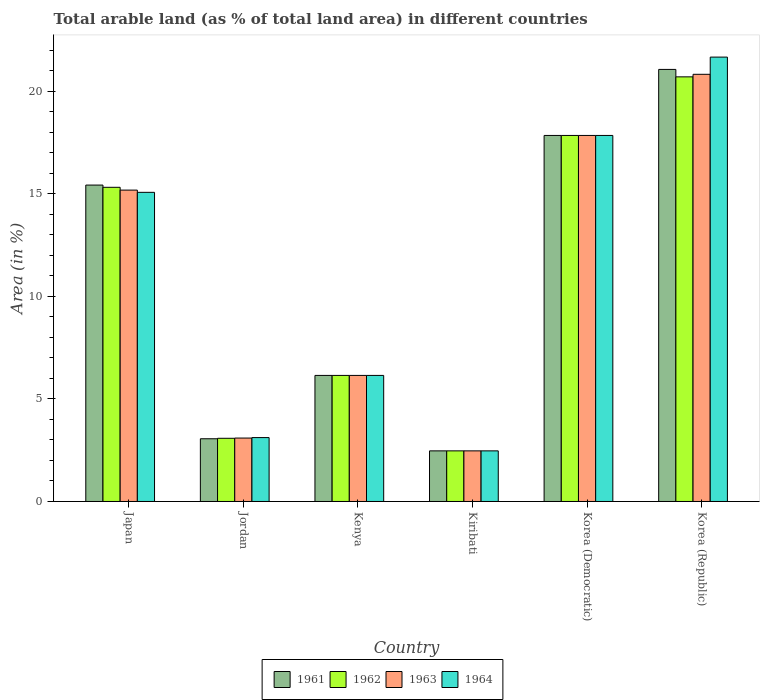How many different coloured bars are there?
Provide a succinct answer. 4. How many groups of bars are there?
Ensure brevity in your answer.  6. Are the number of bars on each tick of the X-axis equal?
Provide a short and direct response. Yes. How many bars are there on the 4th tick from the left?
Provide a short and direct response. 4. What is the label of the 5th group of bars from the left?
Your answer should be compact. Korea (Democratic). In how many cases, is the number of bars for a given country not equal to the number of legend labels?
Offer a terse response. 0. What is the percentage of arable land in 1964 in Japan?
Keep it short and to the point. 15.08. Across all countries, what is the maximum percentage of arable land in 1963?
Keep it short and to the point. 20.84. Across all countries, what is the minimum percentage of arable land in 1962?
Keep it short and to the point. 2.47. In which country was the percentage of arable land in 1962 maximum?
Offer a very short reply. Korea (Republic). In which country was the percentage of arable land in 1964 minimum?
Provide a succinct answer. Kiribati. What is the total percentage of arable land in 1962 in the graph?
Give a very brief answer. 65.6. What is the difference between the percentage of arable land in 1963 in Korea (Democratic) and that in Korea (Republic)?
Offer a very short reply. -2.98. What is the difference between the percentage of arable land in 1962 in Kiribati and the percentage of arable land in 1964 in Kenya?
Offer a terse response. -3.68. What is the average percentage of arable land in 1964 per country?
Make the answer very short. 11.06. What is the ratio of the percentage of arable land in 1964 in Japan to that in Kiribati?
Offer a terse response. 6.11. Is the percentage of arable land in 1963 in Kenya less than that in Kiribati?
Ensure brevity in your answer.  No. Is the difference between the percentage of arable land in 1964 in Jordan and Kiribati greater than the difference between the percentage of arable land in 1963 in Jordan and Kiribati?
Your response must be concise. Yes. What is the difference between the highest and the second highest percentage of arable land in 1963?
Your response must be concise. -2.98. What is the difference between the highest and the lowest percentage of arable land in 1964?
Your response must be concise. 19.21. Is it the case that in every country, the sum of the percentage of arable land in 1961 and percentage of arable land in 1964 is greater than the sum of percentage of arable land in 1963 and percentage of arable land in 1962?
Your answer should be compact. No. What does the 3rd bar from the left in Kenya represents?
Make the answer very short. 1963. How many bars are there?
Offer a very short reply. 24. Are all the bars in the graph horizontal?
Ensure brevity in your answer.  No. How many countries are there in the graph?
Provide a short and direct response. 6. What is the difference between two consecutive major ticks on the Y-axis?
Provide a short and direct response. 5. Does the graph contain grids?
Your answer should be compact. No. How many legend labels are there?
Provide a succinct answer. 4. What is the title of the graph?
Ensure brevity in your answer.  Total arable land (as % of total land area) in different countries. What is the label or title of the Y-axis?
Offer a very short reply. Area (in %). What is the Area (in %) of 1961 in Japan?
Provide a succinct answer. 15.43. What is the Area (in %) in 1962 in Japan?
Offer a very short reply. 15.33. What is the Area (in %) of 1963 in Japan?
Keep it short and to the point. 15.19. What is the Area (in %) of 1964 in Japan?
Provide a short and direct response. 15.08. What is the Area (in %) in 1961 in Jordan?
Your response must be concise. 3.06. What is the Area (in %) of 1962 in Jordan?
Offer a very short reply. 3.08. What is the Area (in %) of 1963 in Jordan?
Keep it short and to the point. 3.09. What is the Area (in %) in 1964 in Jordan?
Give a very brief answer. 3.12. What is the Area (in %) of 1961 in Kenya?
Provide a short and direct response. 6.15. What is the Area (in %) in 1962 in Kenya?
Offer a terse response. 6.15. What is the Area (in %) in 1963 in Kenya?
Ensure brevity in your answer.  6.15. What is the Area (in %) of 1964 in Kenya?
Offer a terse response. 6.15. What is the Area (in %) in 1961 in Kiribati?
Provide a short and direct response. 2.47. What is the Area (in %) of 1962 in Kiribati?
Your response must be concise. 2.47. What is the Area (in %) of 1963 in Kiribati?
Your response must be concise. 2.47. What is the Area (in %) of 1964 in Kiribati?
Provide a succinct answer. 2.47. What is the Area (in %) in 1961 in Korea (Democratic)?
Provide a short and direct response. 17.86. What is the Area (in %) of 1962 in Korea (Democratic)?
Make the answer very short. 17.86. What is the Area (in %) in 1963 in Korea (Democratic)?
Ensure brevity in your answer.  17.86. What is the Area (in %) in 1964 in Korea (Democratic)?
Offer a very short reply. 17.86. What is the Area (in %) of 1961 in Korea (Republic)?
Your answer should be compact. 21.08. What is the Area (in %) of 1962 in Korea (Republic)?
Provide a short and direct response. 20.71. What is the Area (in %) in 1963 in Korea (Republic)?
Keep it short and to the point. 20.84. What is the Area (in %) in 1964 in Korea (Republic)?
Give a very brief answer. 21.68. Across all countries, what is the maximum Area (in %) in 1961?
Keep it short and to the point. 21.08. Across all countries, what is the maximum Area (in %) in 1962?
Provide a short and direct response. 20.71. Across all countries, what is the maximum Area (in %) of 1963?
Keep it short and to the point. 20.84. Across all countries, what is the maximum Area (in %) of 1964?
Provide a short and direct response. 21.68. Across all countries, what is the minimum Area (in %) of 1961?
Your response must be concise. 2.47. Across all countries, what is the minimum Area (in %) of 1962?
Your answer should be very brief. 2.47. Across all countries, what is the minimum Area (in %) in 1963?
Offer a terse response. 2.47. Across all countries, what is the minimum Area (in %) in 1964?
Offer a terse response. 2.47. What is the total Area (in %) in 1961 in the graph?
Your response must be concise. 66.05. What is the total Area (in %) in 1962 in the graph?
Give a very brief answer. 65.6. What is the total Area (in %) in 1963 in the graph?
Ensure brevity in your answer.  65.6. What is the total Area (in %) of 1964 in the graph?
Provide a succinct answer. 66.35. What is the difference between the Area (in %) of 1961 in Japan and that in Jordan?
Offer a terse response. 12.38. What is the difference between the Area (in %) in 1962 in Japan and that in Jordan?
Keep it short and to the point. 12.24. What is the difference between the Area (in %) in 1963 in Japan and that in Jordan?
Offer a terse response. 12.1. What is the difference between the Area (in %) in 1964 in Japan and that in Jordan?
Your answer should be compact. 11.96. What is the difference between the Area (in %) in 1961 in Japan and that in Kenya?
Ensure brevity in your answer.  9.29. What is the difference between the Area (in %) of 1962 in Japan and that in Kenya?
Your response must be concise. 9.18. What is the difference between the Area (in %) of 1963 in Japan and that in Kenya?
Offer a terse response. 9.04. What is the difference between the Area (in %) of 1964 in Japan and that in Kenya?
Provide a succinct answer. 8.93. What is the difference between the Area (in %) of 1961 in Japan and that in Kiribati?
Ensure brevity in your answer.  12.97. What is the difference between the Area (in %) of 1962 in Japan and that in Kiribati?
Ensure brevity in your answer.  12.86. What is the difference between the Area (in %) in 1963 in Japan and that in Kiribati?
Make the answer very short. 12.72. What is the difference between the Area (in %) in 1964 in Japan and that in Kiribati?
Your response must be concise. 12.61. What is the difference between the Area (in %) of 1961 in Japan and that in Korea (Democratic)?
Provide a succinct answer. -2.42. What is the difference between the Area (in %) in 1962 in Japan and that in Korea (Democratic)?
Provide a short and direct response. -2.53. What is the difference between the Area (in %) of 1963 in Japan and that in Korea (Democratic)?
Make the answer very short. -2.67. What is the difference between the Area (in %) in 1964 in Japan and that in Korea (Democratic)?
Your answer should be compact. -2.78. What is the difference between the Area (in %) in 1961 in Japan and that in Korea (Republic)?
Make the answer very short. -5.64. What is the difference between the Area (in %) in 1962 in Japan and that in Korea (Republic)?
Keep it short and to the point. -5.39. What is the difference between the Area (in %) in 1963 in Japan and that in Korea (Republic)?
Provide a succinct answer. -5.65. What is the difference between the Area (in %) in 1964 in Japan and that in Korea (Republic)?
Make the answer very short. -6.6. What is the difference between the Area (in %) in 1961 in Jordan and that in Kenya?
Keep it short and to the point. -3.09. What is the difference between the Area (in %) in 1962 in Jordan and that in Kenya?
Your answer should be very brief. -3.07. What is the difference between the Area (in %) in 1963 in Jordan and that in Kenya?
Keep it short and to the point. -3.06. What is the difference between the Area (in %) of 1964 in Jordan and that in Kenya?
Your answer should be very brief. -3.03. What is the difference between the Area (in %) of 1961 in Jordan and that in Kiribati?
Give a very brief answer. 0.59. What is the difference between the Area (in %) in 1962 in Jordan and that in Kiribati?
Make the answer very short. 0.61. What is the difference between the Area (in %) of 1963 in Jordan and that in Kiribati?
Ensure brevity in your answer.  0.62. What is the difference between the Area (in %) of 1964 in Jordan and that in Kiribati?
Your answer should be very brief. 0.65. What is the difference between the Area (in %) in 1961 in Jordan and that in Korea (Democratic)?
Give a very brief answer. -14.8. What is the difference between the Area (in %) of 1962 in Jordan and that in Korea (Democratic)?
Offer a very short reply. -14.77. What is the difference between the Area (in %) of 1963 in Jordan and that in Korea (Democratic)?
Make the answer very short. -14.76. What is the difference between the Area (in %) in 1964 in Jordan and that in Korea (Democratic)?
Make the answer very short. -14.74. What is the difference between the Area (in %) of 1961 in Jordan and that in Korea (Republic)?
Your answer should be very brief. -18.02. What is the difference between the Area (in %) in 1962 in Jordan and that in Korea (Republic)?
Keep it short and to the point. -17.63. What is the difference between the Area (in %) of 1963 in Jordan and that in Korea (Republic)?
Offer a terse response. -17.74. What is the difference between the Area (in %) in 1964 in Jordan and that in Korea (Republic)?
Give a very brief answer. -18.56. What is the difference between the Area (in %) in 1961 in Kenya and that in Kiribati?
Your response must be concise. 3.68. What is the difference between the Area (in %) of 1962 in Kenya and that in Kiribati?
Your answer should be compact. 3.68. What is the difference between the Area (in %) of 1963 in Kenya and that in Kiribati?
Provide a short and direct response. 3.68. What is the difference between the Area (in %) in 1964 in Kenya and that in Kiribati?
Offer a very short reply. 3.68. What is the difference between the Area (in %) of 1961 in Kenya and that in Korea (Democratic)?
Your response must be concise. -11.71. What is the difference between the Area (in %) of 1962 in Kenya and that in Korea (Democratic)?
Ensure brevity in your answer.  -11.71. What is the difference between the Area (in %) of 1963 in Kenya and that in Korea (Democratic)?
Your answer should be compact. -11.71. What is the difference between the Area (in %) of 1964 in Kenya and that in Korea (Democratic)?
Give a very brief answer. -11.71. What is the difference between the Area (in %) of 1961 in Kenya and that in Korea (Republic)?
Give a very brief answer. -14.93. What is the difference between the Area (in %) in 1962 in Kenya and that in Korea (Republic)?
Your answer should be very brief. -14.56. What is the difference between the Area (in %) of 1963 in Kenya and that in Korea (Republic)?
Offer a terse response. -14.69. What is the difference between the Area (in %) of 1964 in Kenya and that in Korea (Republic)?
Provide a succinct answer. -15.53. What is the difference between the Area (in %) in 1961 in Kiribati and that in Korea (Democratic)?
Provide a short and direct response. -15.39. What is the difference between the Area (in %) in 1962 in Kiribati and that in Korea (Democratic)?
Ensure brevity in your answer.  -15.39. What is the difference between the Area (in %) in 1963 in Kiribati and that in Korea (Democratic)?
Make the answer very short. -15.39. What is the difference between the Area (in %) in 1964 in Kiribati and that in Korea (Democratic)?
Ensure brevity in your answer.  -15.39. What is the difference between the Area (in %) of 1961 in Kiribati and that in Korea (Republic)?
Ensure brevity in your answer.  -18.61. What is the difference between the Area (in %) in 1962 in Kiribati and that in Korea (Republic)?
Your answer should be compact. -18.24. What is the difference between the Area (in %) of 1963 in Kiribati and that in Korea (Republic)?
Offer a terse response. -18.37. What is the difference between the Area (in %) in 1964 in Kiribati and that in Korea (Republic)?
Your response must be concise. -19.21. What is the difference between the Area (in %) in 1961 in Korea (Democratic) and that in Korea (Republic)?
Give a very brief answer. -3.22. What is the difference between the Area (in %) of 1962 in Korea (Democratic) and that in Korea (Republic)?
Your answer should be very brief. -2.86. What is the difference between the Area (in %) of 1963 in Korea (Democratic) and that in Korea (Republic)?
Give a very brief answer. -2.98. What is the difference between the Area (in %) of 1964 in Korea (Democratic) and that in Korea (Republic)?
Keep it short and to the point. -3.82. What is the difference between the Area (in %) of 1961 in Japan and the Area (in %) of 1962 in Jordan?
Your answer should be compact. 12.35. What is the difference between the Area (in %) of 1961 in Japan and the Area (in %) of 1963 in Jordan?
Offer a terse response. 12.34. What is the difference between the Area (in %) of 1961 in Japan and the Area (in %) of 1964 in Jordan?
Ensure brevity in your answer.  12.32. What is the difference between the Area (in %) of 1962 in Japan and the Area (in %) of 1963 in Jordan?
Provide a short and direct response. 12.23. What is the difference between the Area (in %) of 1962 in Japan and the Area (in %) of 1964 in Jordan?
Offer a terse response. 12.21. What is the difference between the Area (in %) of 1963 in Japan and the Area (in %) of 1964 in Jordan?
Ensure brevity in your answer.  12.07. What is the difference between the Area (in %) in 1961 in Japan and the Area (in %) in 1962 in Kenya?
Provide a short and direct response. 9.29. What is the difference between the Area (in %) in 1961 in Japan and the Area (in %) in 1963 in Kenya?
Offer a terse response. 9.29. What is the difference between the Area (in %) of 1961 in Japan and the Area (in %) of 1964 in Kenya?
Give a very brief answer. 9.29. What is the difference between the Area (in %) of 1962 in Japan and the Area (in %) of 1963 in Kenya?
Keep it short and to the point. 9.18. What is the difference between the Area (in %) in 1962 in Japan and the Area (in %) in 1964 in Kenya?
Make the answer very short. 9.18. What is the difference between the Area (in %) of 1963 in Japan and the Area (in %) of 1964 in Kenya?
Provide a short and direct response. 9.04. What is the difference between the Area (in %) in 1961 in Japan and the Area (in %) in 1962 in Kiribati?
Offer a very short reply. 12.97. What is the difference between the Area (in %) in 1961 in Japan and the Area (in %) in 1963 in Kiribati?
Provide a short and direct response. 12.97. What is the difference between the Area (in %) of 1961 in Japan and the Area (in %) of 1964 in Kiribati?
Make the answer very short. 12.97. What is the difference between the Area (in %) in 1962 in Japan and the Area (in %) in 1963 in Kiribati?
Your answer should be compact. 12.86. What is the difference between the Area (in %) in 1962 in Japan and the Area (in %) in 1964 in Kiribati?
Your answer should be compact. 12.86. What is the difference between the Area (in %) in 1963 in Japan and the Area (in %) in 1964 in Kiribati?
Provide a succinct answer. 12.72. What is the difference between the Area (in %) of 1961 in Japan and the Area (in %) of 1962 in Korea (Democratic)?
Provide a short and direct response. -2.42. What is the difference between the Area (in %) of 1961 in Japan and the Area (in %) of 1963 in Korea (Democratic)?
Your answer should be very brief. -2.42. What is the difference between the Area (in %) of 1961 in Japan and the Area (in %) of 1964 in Korea (Democratic)?
Keep it short and to the point. -2.42. What is the difference between the Area (in %) of 1962 in Japan and the Area (in %) of 1963 in Korea (Democratic)?
Offer a very short reply. -2.53. What is the difference between the Area (in %) of 1962 in Japan and the Area (in %) of 1964 in Korea (Democratic)?
Your answer should be very brief. -2.53. What is the difference between the Area (in %) in 1963 in Japan and the Area (in %) in 1964 in Korea (Democratic)?
Offer a terse response. -2.67. What is the difference between the Area (in %) of 1961 in Japan and the Area (in %) of 1962 in Korea (Republic)?
Your response must be concise. -5.28. What is the difference between the Area (in %) of 1961 in Japan and the Area (in %) of 1963 in Korea (Republic)?
Provide a short and direct response. -5.4. What is the difference between the Area (in %) of 1961 in Japan and the Area (in %) of 1964 in Korea (Republic)?
Your response must be concise. -6.24. What is the difference between the Area (in %) of 1962 in Japan and the Area (in %) of 1963 in Korea (Republic)?
Ensure brevity in your answer.  -5.51. What is the difference between the Area (in %) of 1962 in Japan and the Area (in %) of 1964 in Korea (Republic)?
Your answer should be compact. -6.35. What is the difference between the Area (in %) in 1963 in Japan and the Area (in %) in 1964 in Korea (Republic)?
Offer a very short reply. -6.49. What is the difference between the Area (in %) of 1961 in Jordan and the Area (in %) of 1962 in Kenya?
Your response must be concise. -3.09. What is the difference between the Area (in %) of 1961 in Jordan and the Area (in %) of 1963 in Kenya?
Your response must be concise. -3.09. What is the difference between the Area (in %) of 1961 in Jordan and the Area (in %) of 1964 in Kenya?
Your response must be concise. -3.09. What is the difference between the Area (in %) of 1962 in Jordan and the Area (in %) of 1963 in Kenya?
Keep it short and to the point. -3.07. What is the difference between the Area (in %) of 1962 in Jordan and the Area (in %) of 1964 in Kenya?
Offer a terse response. -3.07. What is the difference between the Area (in %) in 1963 in Jordan and the Area (in %) in 1964 in Kenya?
Offer a terse response. -3.06. What is the difference between the Area (in %) in 1961 in Jordan and the Area (in %) in 1962 in Kiribati?
Make the answer very short. 0.59. What is the difference between the Area (in %) of 1961 in Jordan and the Area (in %) of 1963 in Kiribati?
Give a very brief answer. 0.59. What is the difference between the Area (in %) of 1961 in Jordan and the Area (in %) of 1964 in Kiribati?
Ensure brevity in your answer.  0.59. What is the difference between the Area (in %) of 1962 in Jordan and the Area (in %) of 1963 in Kiribati?
Ensure brevity in your answer.  0.61. What is the difference between the Area (in %) in 1962 in Jordan and the Area (in %) in 1964 in Kiribati?
Keep it short and to the point. 0.61. What is the difference between the Area (in %) in 1963 in Jordan and the Area (in %) in 1964 in Kiribati?
Keep it short and to the point. 0.62. What is the difference between the Area (in %) of 1961 in Jordan and the Area (in %) of 1962 in Korea (Democratic)?
Your answer should be compact. -14.8. What is the difference between the Area (in %) in 1961 in Jordan and the Area (in %) in 1963 in Korea (Democratic)?
Offer a terse response. -14.8. What is the difference between the Area (in %) in 1961 in Jordan and the Area (in %) in 1964 in Korea (Democratic)?
Ensure brevity in your answer.  -14.8. What is the difference between the Area (in %) in 1962 in Jordan and the Area (in %) in 1963 in Korea (Democratic)?
Ensure brevity in your answer.  -14.77. What is the difference between the Area (in %) of 1962 in Jordan and the Area (in %) of 1964 in Korea (Democratic)?
Offer a very short reply. -14.77. What is the difference between the Area (in %) of 1963 in Jordan and the Area (in %) of 1964 in Korea (Democratic)?
Your answer should be compact. -14.76. What is the difference between the Area (in %) of 1961 in Jordan and the Area (in %) of 1962 in Korea (Republic)?
Your answer should be very brief. -17.65. What is the difference between the Area (in %) in 1961 in Jordan and the Area (in %) in 1963 in Korea (Republic)?
Offer a very short reply. -17.78. What is the difference between the Area (in %) in 1961 in Jordan and the Area (in %) in 1964 in Korea (Republic)?
Give a very brief answer. -18.62. What is the difference between the Area (in %) in 1962 in Jordan and the Area (in %) in 1963 in Korea (Republic)?
Make the answer very short. -17.76. What is the difference between the Area (in %) of 1962 in Jordan and the Area (in %) of 1964 in Korea (Republic)?
Your answer should be very brief. -18.59. What is the difference between the Area (in %) in 1963 in Jordan and the Area (in %) in 1964 in Korea (Republic)?
Ensure brevity in your answer.  -18.58. What is the difference between the Area (in %) of 1961 in Kenya and the Area (in %) of 1962 in Kiribati?
Give a very brief answer. 3.68. What is the difference between the Area (in %) of 1961 in Kenya and the Area (in %) of 1963 in Kiribati?
Provide a succinct answer. 3.68. What is the difference between the Area (in %) of 1961 in Kenya and the Area (in %) of 1964 in Kiribati?
Your answer should be very brief. 3.68. What is the difference between the Area (in %) of 1962 in Kenya and the Area (in %) of 1963 in Kiribati?
Provide a succinct answer. 3.68. What is the difference between the Area (in %) in 1962 in Kenya and the Area (in %) in 1964 in Kiribati?
Your answer should be compact. 3.68. What is the difference between the Area (in %) of 1963 in Kenya and the Area (in %) of 1964 in Kiribati?
Make the answer very short. 3.68. What is the difference between the Area (in %) in 1961 in Kenya and the Area (in %) in 1962 in Korea (Democratic)?
Offer a terse response. -11.71. What is the difference between the Area (in %) of 1961 in Kenya and the Area (in %) of 1963 in Korea (Democratic)?
Your answer should be very brief. -11.71. What is the difference between the Area (in %) in 1961 in Kenya and the Area (in %) in 1964 in Korea (Democratic)?
Provide a short and direct response. -11.71. What is the difference between the Area (in %) of 1962 in Kenya and the Area (in %) of 1963 in Korea (Democratic)?
Your answer should be very brief. -11.71. What is the difference between the Area (in %) in 1962 in Kenya and the Area (in %) in 1964 in Korea (Democratic)?
Offer a terse response. -11.71. What is the difference between the Area (in %) of 1963 in Kenya and the Area (in %) of 1964 in Korea (Democratic)?
Ensure brevity in your answer.  -11.71. What is the difference between the Area (in %) of 1961 in Kenya and the Area (in %) of 1962 in Korea (Republic)?
Ensure brevity in your answer.  -14.56. What is the difference between the Area (in %) in 1961 in Kenya and the Area (in %) in 1963 in Korea (Republic)?
Offer a very short reply. -14.69. What is the difference between the Area (in %) of 1961 in Kenya and the Area (in %) of 1964 in Korea (Republic)?
Your response must be concise. -15.53. What is the difference between the Area (in %) in 1962 in Kenya and the Area (in %) in 1963 in Korea (Republic)?
Make the answer very short. -14.69. What is the difference between the Area (in %) in 1962 in Kenya and the Area (in %) in 1964 in Korea (Republic)?
Provide a short and direct response. -15.53. What is the difference between the Area (in %) in 1963 in Kenya and the Area (in %) in 1964 in Korea (Republic)?
Offer a terse response. -15.53. What is the difference between the Area (in %) in 1961 in Kiribati and the Area (in %) in 1962 in Korea (Democratic)?
Offer a very short reply. -15.39. What is the difference between the Area (in %) of 1961 in Kiribati and the Area (in %) of 1963 in Korea (Democratic)?
Your answer should be very brief. -15.39. What is the difference between the Area (in %) in 1961 in Kiribati and the Area (in %) in 1964 in Korea (Democratic)?
Offer a very short reply. -15.39. What is the difference between the Area (in %) in 1962 in Kiribati and the Area (in %) in 1963 in Korea (Democratic)?
Provide a succinct answer. -15.39. What is the difference between the Area (in %) in 1962 in Kiribati and the Area (in %) in 1964 in Korea (Democratic)?
Give a very brief answer. -15.39. What is the difference between the Area (in %) in 1963 in Kiribati and the Area (in %) in 1964 in Korea (Democratic)?
Keep it short and to the point. -15.39. What is the difference between the Area (in %) in 1961 in Kiribati and the Area (in %) in 1962 in Korea (Republic)?
Give a very brief answer. -18.24. What is the difference between the Area (in %) of 1961 in Kiribati and the Area (in %) of 1963 in Korea (Republic)?
Offer a very short reply. -18.37. What is the difference between the Area (in %) in 1961 in Kiribati and the Area (in %) in 1964 in Korea (Republic)?
Your response must be concise. -19.21. What is the difference between the Area (in %) of 1962 in Kiribati and the Area (in %) of 1963 in Korea (Republic)?
Your answer should be very brief. -18.37. What is the difference between the Area (in %) of 1962 in Kiribati and the Area (in %) of 1964 in Korea (Republic)?
Provide a succinct answer. -19.21. What is the difference between the Area (in %) of 1963 in Kiribati and the Area (in %) of 1964 in Korea (Republic)?
Provide a short and direct response. -19.21. What is the difference between the Area (in %) of 1961 in Korea (Democratic) and the Area (in %) of 1962 in Korea (Republic)?
Ensure brevity in your answer.  -2.86. What is the difference between the Area (in %) of 1961 in Korea (Democratic) and the Area (in %) of 1963 in Korea (Republic)?
Provide a succinct answer. -2.98. What is the difference between the Area (in %) of 1961 in Korea (Democratic) and the Area (in %) of 1964 in Korea (Republic)?
Provide a succinct answer. -3.82. What is the difference between the Area (in %) in 1962 in Korea (Democratic) and the Area (in %) in 1963 in Korea (Republic)?
Your answer should be very brief. -2.98. What is the difference between the Area (in %) of 1962 in Korea (Democratic) and the Area (in %) of 1964 in Korea (Republic)?
Give a very brief answer. -3.82. What is the difference between the Area (in %) of 1963 in Korea (Democratic) and the Area (in %) of 1964 in Korea (Republic)?
Provide a succinct answer. -3.82. What is the average Area (in %) in 1961 per country?
Your answer should be compact. 11.01. What is the average Area (in %) in 1962 per country?
Your answer should be compact. 10.93. What is the average Area (in %) of 1963 per country?
Offer a terse response. 10.93. What is the average Area (in %) in 1964 per country?
Your answer should be very brief. 11.06. What is the difference between the Area (in %) of 1961 and Area (in %) of 1962 in Japan?
Keep it short and to the point. 0.11. What is the difference between the Area (in %) of 1961 and Area (in %) of 1963 in Japan?
Your response must be concise. 0.25. What is the difference between the Area (in %) of 1961 and Area (in %) of 1964 in Japan?
Give a very brief answer. 0.35. What is the difference between the Area (in %) of 1962 and Area (in %) of 1963 in Japan?
Offer a very short reply. 0.14. What is the difference between the Area (in %) of 1962 and Area (in %) of 1964 in Japan?
Provide a succinct answer. 0.25. What is the difference between the Area (in %) of 1963 and Area (in %) of 1964 in Japan?
Offer a terse response. 0.11. What is the difference between the Area (in %) of 1961 and Area (in %) of 1962 in Jordan?
Your answer should be very brief. -0.02. What is the difference between the Area (in %) of 1961 and Area (in %) of 1963 in Jordan?
Your answer should be very brief. -0.03. What is the difference between the Area (in %) of 1961 and Area (in %) of 1964 in Jordan?
Keep it short and to the point. -0.06. What is the difference between the Area (in %) of 1962 and Area (in %) of 1963 in Jordan?
Your answer should be very brief. -0.01. What is the difference between the Area (in %) of 1962 and Area (in %) of 1964 in Jordan?
Make the answer very short. -0.03. What is the difference between the Area (in %) in 1963 and Area (in %) in 1964 in Jordan?
Your answer should be compact. -0.02. What is the difference between the Area (in %) in 1961 and Area (in %) in 1962 in Kenya?
Keep it short and to the point. 0. What is the difference between the Area (in %) of 1962 and Area (in %) of 1963 in Kenya?
Offer a terse response. 0. What is the difference between the Area (in %) in 1963 and Area (in %) in 1964 in Kenya?
Offer a terse response. 0. What is the difference between the Area (in %) in 1961 and Area (in %) in 1964 in Kiribati?
Give a very brief answer. 0. What is the difference between the Area (in %) in 1961 and Area (in %) in 1963 in Korea (Democratic)?
Provide a short and direct response. 0. What is the difference between the Area (in %) in 1961 and Area (in %) in 1964 in Korea (Democratic)?
Give a very brief answer. 0. What is the difference between the Area (in %) of 1962 and Area (in %) of 1963 in Korea (Democratic)?
Provide a succinct answer. 0. What is the difference between the Area (in %) in 1962 and Area (in %) in 1964 in Korea (Democratic)?
Your answer should be very brief. 0. What is the difference between the Area (in %) of 1963 and Area (in %) of 1964 in Korea (Democratic)?
Make the answer very short. 0. What is the difference between the Area (in %) of 1961 and Area (in %) of 1962 in Korea (Republic)?
Ensure brevity in your answer.  0.36. What is the difference between the Area (in %) of 1961 and Area (in %) of 1963 in Korea (Republic)?
Make the answer very short. 0.24. What is the difference between the Area (in %) in 1961 and Area (in %) in 1964 in Korea (Republic)?
Your response must be concise. -0.6. What is the difference between the Area (in %) in 1962 and Area (in %) in 1963 in Korea (Republic)?
Give a very brief answer. -0.12. What is the difference between the Area (in %) of 1962 and Area (in %) of 1964 in Korea (Republic)?
Your answer should be very brief. -0.96. What is the difference between the Area (in %) in 1963 and Area (in %) in 1964 in Korea (Republic)?
Keep it short and to the point. -0.84. What is the ratio of the Area (in %) of 1961 in Japan to that in Jordan?
Offer a terse response. 5.04. What is the ratio of the Area (in %) in 1962 in Japan to that in Jordan?
Make the answer very short. 4.97. What is the ratio of the Area (in %) in 1963 in Japan to that in Jordan?
Provide a succinct answer. 4.91. What is the ratio of the Area (in %) of 1964 in Japan to that in Jordan?
Give a very brief answer. 4.84. What is the ratio of the Area (in %) in 1961 in Japan to that in Kenya?
Your answer should be compact. 2.51. What is the ratio of the Area (in %) of 1962 in Japan to that in Kenya?
Offer a very short reply. 2.49. What is the ratio of the Area (in %) of 1963 in Japan to that in Kenya?
Offer a terse response. 2.47. What is the ratio of the Area (in %) of 1964 in Japan to that in Kenya?
Provide a succinct answer. 2.45. What is the ratio of the Area (in %) in 1961 in Japan to that in Kiribati?
Ensure brevity in your answer.  6.25. What is the ratio of the Area (in %) in 1962 in Japan to that in Kiribati?
Ensure brevity in your answer.  6.21. What is the ratio of the Area (in %) of 1963 in Japan to that in Kiribati?
Keep it short and to the point. 6.15. What is the ratio of the Area (in %) in 1964 in Japan to that in Kiribati?
Your response must be concise. 6.11. What is the ratio of the Area (in %) of 1961 in Japan to that in Korea (Democratic)?
Your response must be concise. 0.86. What is the ratio of the Area (in %) of 1962 in Japan to that in Korea (Democratic)?
Give a very brief answer. 0.86. What is the ratio of the Area (in %) of 1963 in Japan to that in Korea (Democratic)?
Keep it short and to the point. 0.85. What is the ratio of the Area (in %) of 1964 in Japan to that in Korea (Democratic)?
Make the answer very short. 0.84. What is the ratio of the Area (in %) in 1961 in Japan to that in Korea (Republic)?
Keep it short and to the point. 0.73. What is the ratio of the Area (in %) of 1962 in Japan to that in Korea (Republic)?
Give a very brief answer. 0.74. What is the ratio of the Area (in %) of 1963 in Japan to that in Korea (Republic)?
Your response must be concise. 0.73. What is the ratio of the Area (in %) in 1964 in Japan to that in Korea (Republic)?
Make the answer very short. 0.7. What is the ratio of the Area (in %) in 1961 in Jordan to that in Kenya?
Offer a very short reply. 0.5. What is the ratio of the Area (in %) in 1962 in Jordan to that in Kenya?
Keep it short and to the point. 0.5. What is the ratio of the Area (in %) of 1963 in Jordan to that in Kenya?
Keep it short and to the point. 0.5. What is the ratio of the Area (in %) in 1964 in Jordan to that in Kenya?
Offer a very short reply. 0.51. What is the ratio of the Area (in %) in 1961 in Jordan to that in Kiribati?
Your answer should be very brief. 1.24. What is the ratio of the Area (in %) of 1962 in Jordan to that in Kiribati?
Ensure brevity in your answer.  1.25. What is the ratio of the Area (in %) in 1963 in Jordan to that in Kiribati?
Make the answer very short. 1.25. What is the ratio of the Area (in %) of 1964 in Jordan to that in Kiribati?
Give a very brief answer. 1.26. What is the ratio of the Area (in %) in 1961 in Jordan to that in Korea (Democratic)?
Offer a very short reply. 0.17. What is the ratio of the Area (in %) of 1962 in Jordan to that in Korea (Democratic)?
Make the answer very short. 0.17. What is the ratio of the Area (in %) of 1963 in Jordan to that in Korea (Democratic)?
Your answer should be compact. 0.17. What is the ratio of the Area (in %) in 1964 in Jordan to that in Korea (Democratic)?
Your response must be concise. 0.17. What is the ratio of the Area (in %) of 1961 in Jordan to that in Korea (Republic)?
Provide a succinct answer. 0.15. What is the ratio of the Area (in %) in 1962 in Jordan to that in Korea (Republic)?
Make the answer very short. 0.15. What is the ratio of the Area (in %) of 1963 in Jordan to that in Korea (Republic)?
Offer a very short reply. 0.15. What is the ratio of the Area (in %) of 1964 in Jordan to that in Korea (Republic)?
Give a very brief answer. 0.14. What is the ratio of the Area (in %) of 1961 in Kenya to that in Kiribati?
Keep it short and to the point. 2.49. What is the ratio of the Area (in %) of 1962 in Kenya to that in Kiribati?
Offer a very short reply. 2.49. What is the ratio of the Area (in %) in 1963 in Kenya to that in Kiribati?
Make the answer very short. 2.49. What is the ratio of the Area (in %) of 1964 in Kenya to that in Kiribati?
Your answer should be very brief. 2.49. What is the ratio of the Area (in %) of 1961 in Kenya to that in Korea (Democratic)?
Provide a succinct answer. 0.34. What is the ratio of the Area (in %) in 1962 in Kenya to that in Korea (Democratic)?
Provide a succinct answer. 0.34. What is the ratio of the Area (in %) in 1963 in Kenya to that in Korea (Democratic)?
Your answer should be compact. 0.34. What is the ratio of the Area (in %) of 1964 in Kenya to that in Korea (Democratic)?
Make the answer very short. 0.34. What is the ratio of the Area (in %) in 1961 in Kenya to that in Korea (Republic)?
Offer a very short reply. 0.29. What is the ratio of the Area (in %) in 1962 in Kenya to that in Korea (Republic)?
Make the answer very short. 0.3. What is the ratio of the Area (in %) in 1963 in Kenya to that in Korea (Republic)?
Your response must be concise. 0.3. What is the ratio of the Area (in %) in 1964 in Kenya to that in Korea (Republic)?
Make the answer very short. 0.28. What is the ratio of the Area (in %) of 1961 in Kiribati to that in Korea (Democratic)?
Ensure brevity in your answer.  0.14. What is the ratio of the Area (in %) of 1962 in Kiribati to that in Korea (Democratic)?
Your answer should be very brief. 0.14. What is the ratio of the Area (in %) in 1963 in Kiribati to that in Korea (Democratic)?
Provide a short and direct response. 0.14. What is the ratio of the Area (in %) of 1964 in Kiribati to that in Korea (Democratic)?
Provide a succinct answer. 0.14. What is the ratio of the Area (in %) in 1961 in Kiribati to that in Korea (Republic)?
Your response must be concise. 0.12. What is the ratio of the Area (in %) in 1962 in Kiribati to that in Korea (Republic)?
Your response must be concise. 0.12. What is the ratio of the Area (in %) of 1963 in Kiribati to that in Korea (Republic)?
Provide a short and direct response. 0.12. What is the ratio of the Area (in %) of 1964 in Kiribati to that in Korea (Republic)?
Your response must be concise. 0.11. What is the ratio of the Area (in %) in 1961 in Korea (Democratic) to that in Korea (Republic)?
Give a very brief answer. 0.85. What is the ratio of the Area (in %) of 1962 in Korea (Democratic) to that in Korea (Republic)?
Ensure brevity in your answer.  0.86. What is the ratio of the Area (in %) in 1963 in Korea (Democratic) to that in Korea (Republic)?
Your answer should be compact. 0.86. What is the ratio of the Area (in %) in 1964 in Korea (Democratic) to that in Korea (Republic)?
Make the answer very short. 0.82. What is the difference between the highest and the second highest Area (in %) in 1961?
Keep it short and to the point. 3.22. What is the difference between the highest and the second highest Area (in %) of 1962?
Provide a succinct answer. 2.86. What is the difference between the highest and the second highest Area (in %) in 1963?
Your answer should be compact. 2.98. What is the difference between the highest and the second highest Area (in %) of 1964?
Provide a short and direct response. 3.82. What is the difference between the highest and the lowest Area (in %) in 1961?
Ensure brevity in your answer.  18.61. What is the difference between the highest and the lowest Area (in %) in 1962?
Keep it short and to the point. 18.24. What is the difference between the highest and the lowest Area (in %) of 1963?
Keep it short and to the point. 18.37. What is the difference between the highest and the lowest Area (in %) of 1964?
Offer a terse response. 19.21. 